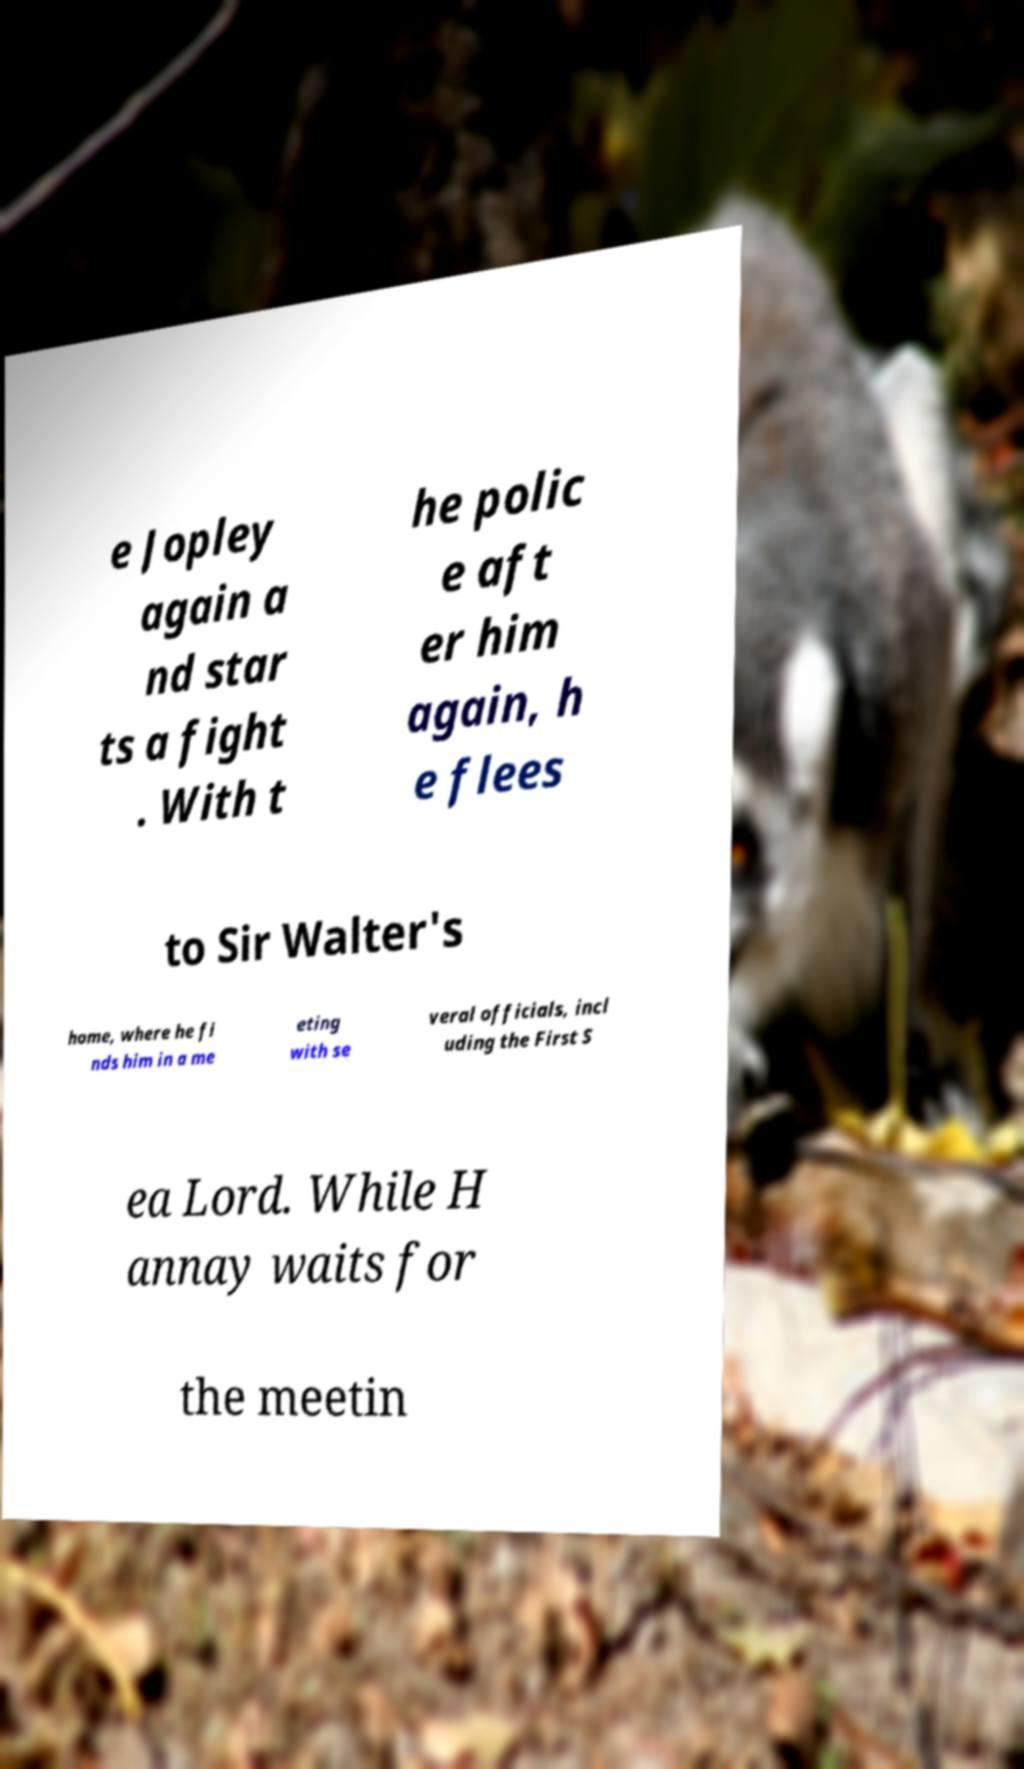For documentation purposes, I need the text within this image transcribed. Could you provide that? e Jopley again a nd star ts a fight . With t he polic e aft er him again, h e flees to Sir Walter's home, where he fi nds him in a me eting with se veral officials, incl uding the First S ea Lord. While H annay waits for the meetin 